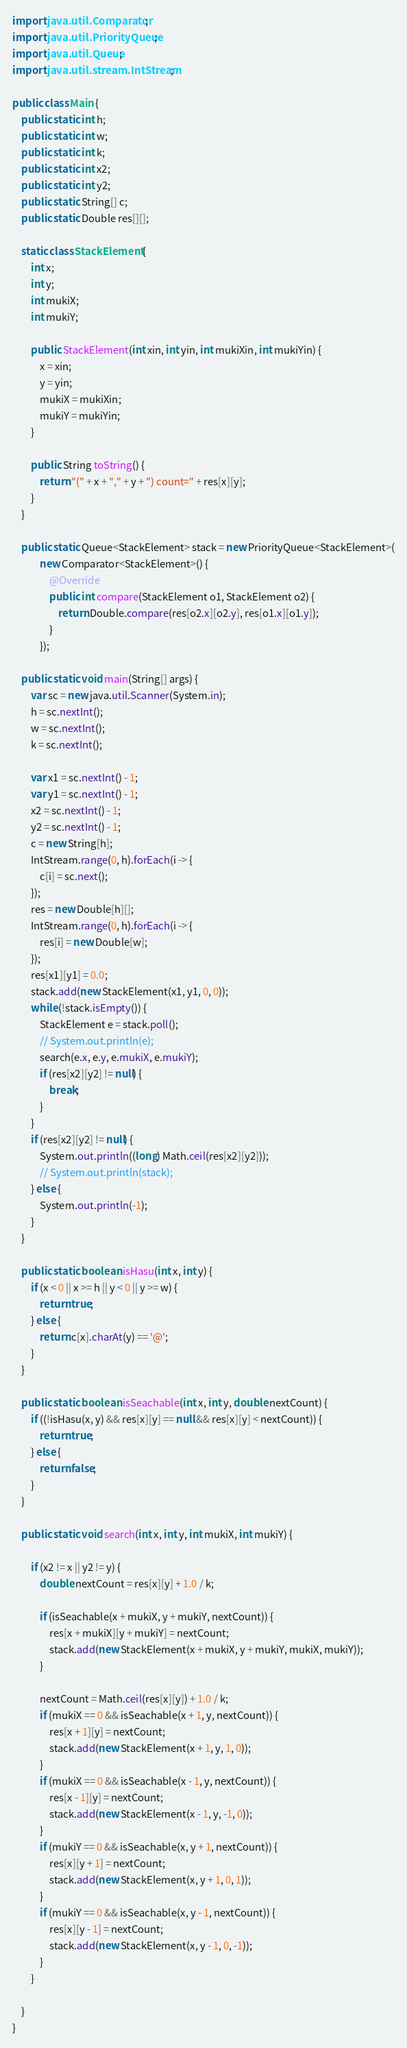Convert code to text. <code><loc_0><loc_0><loc_500><loc_500><_Java_>import java.util.Comparator;
import java.util.PriorityQueue;
import java.util.Queue;
import java.util.stream.IntStream;

public class Main {
    public static int h;
    public static int w;
    public static int k;
    public static int x2;
    public static int y2;
    public static String[] c;
    public static Double res[][];

    static class StackElement {
        int x;
        int y;
        int mukiX;
        int mukiY;

        public StackElement(int xin, int yin, int mukiXin, int mukiYin) {
            x = xin;
            y = yin;
            mukiX = mukiXin;
            mukiY = mukiYin;
        }

        public String toString() {
            return "(" + x + "," + y + ") count=" + res[x][y];
        }
    }

    public static Queue<StackElement> stack = new PriorityQueue<StackElement>(
            new Comparator<StackElement>() {
                @Override
                public int compare(StackElement o1, StackElement o2) {
                    return Double.compare(res[o2.x][o2.y], res[o1.x][o1.y]);
                }
            });

    public static void main(String[] args) {
        var sc = new java.util.Scanner(System.in);
        h = sc.nextInt();
        w = sc.nextInt();
        k = sc.nextInt();

        var x1 = sc.nextInt() - 1;
        var y1 = sc.nextInt() - 1;
        x2 = sc.nextInt() - 1;
        y2 = sc.nextInt() - 1;
        c = new String[h];
        IntStream.range(0, h).forEach(i -> {
            c[i] = sc.next();
        });
        res = new Double[h][];
        IntStream.range(0, h).forEach(i -> {
            res[i] = new Double[w];
        });
        res[x1][y1] = 0.0;
        stack.add(new StackElement(x1, y1, 0, 0));
        while (!stack.isEmpty()) {
            StackElement e = stack.poll();
            // System.out.println(e);
            search(e.x, e.y, e.mukiX, e.mukiY);
            if (res[x2][y2] != null) {
                break;
            }
        }
        if (res[x2][y2] != null) {
            System.out.println((long) Math.ceil(res[x2][y2]));
            // System.out.println(stack);
        } else {
            System.out.println(-1);
        }
    }

    public static boolean isHasu(int x, int y) {
        if (x < 0 || x >= h || y < 0 || y >= w) {
            return true;
        } else {
            return c[x].charAt(y) == '@';
        }
    }

    public static boolean isSeachable(int x, int y, double nextCount) {
        if ((!isHasu(x, y) && res[x][y] == null && res[x][y] < nextCount)) {
            return true;
        } else {
            return false;
        }
    }

    public static void search(int x, int y, int mukiX, int mukiY) {

        if (x2 != x || y2 != y) {
            double nextCount = res[x][y] + 1.0 / k;

            if (isSeachable(x + mukiX, y + mukiY, nextCount)) {
                res[x + mukiX][y + mukiY] = nextCount;
                stack.add(new StackElement(x + mukiX, y + mukiY, mukiX, mukiY));
            }

            nextCount = Math.ceil(res[x][y]) + 1.0 / k;
            if (mukiX == 0 && isSeachable(x + 1, y, nextCount)) {
                res[x + 1][y] = nextCount;
                stack.add(new StackElement(x + 1, y, 1, 0));
            }
            if (mukiX == 0 && isSeachable(x - 1, y, nextCount)) {
                res[x - 1][y] = nextCount;
                stack.add(new StackElement(x - 1, y, -1, 0));
            }
            if (mukiY == 0 && isSeachable(x, y + 1, nextCount)) {
                res[x][y + 1] = nextCount;
                stack.add(new StackElement(x, y + 1, 0, 1));
            }
            if (mukiY == 0 && isSeachable(x, y - 1, nextCount)) {
                res[x][y - 1] = nextCount;
                stack.add(new StackElement(x, y - 1, 0, -1));
            }
        }

    }
}
</code> 